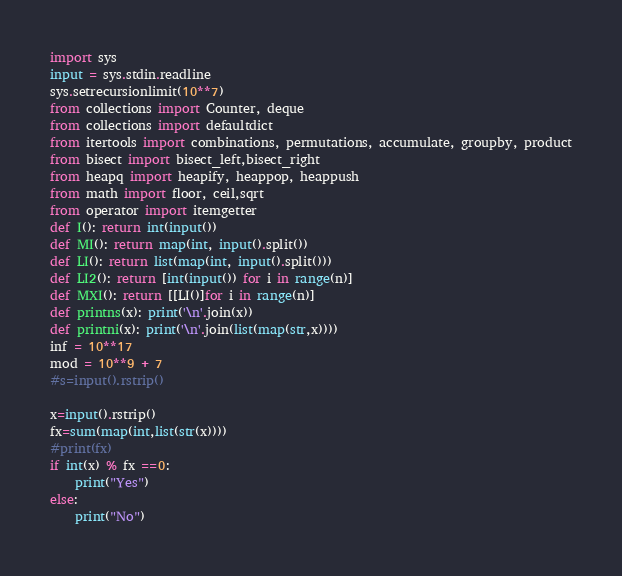<code> <loc_0><loc_0><loc_500><loc_500><_Python_>import sys
input = sys.stdin.readline
sys.setrecursionlimit(10**7)
from collections import Counter, deque
from collections import defaultdict
from itertools import combinations, permutations, accumulate, groupby, product
from bisect import bisect_left,bisect_right
from heapq import heapify, heappop, heappush
from math import floor, ceil,sqrt
from operator import itemgetter
def I(): return int(input())
def MI(): return map(int, input().split())
def LI(): return list(map(int, input().split()))
def LI2(): return [int(input()) for i in range(n)]
def MXI(): return [[LI()]for i in range(n)]
def printns(x): print('\n'.join(x))
def printni(x): print('\n'.join(list(map(str,x))))
inf = 10**17
mod = 10**9 + 7
#s=input().rstrip()

x=input().rstrip()
fx=sum(map(int,list(str(x))))
#print(fx)
if int(x) % fx ==0:
    print("Yes")
else:
    print("No")</code> 